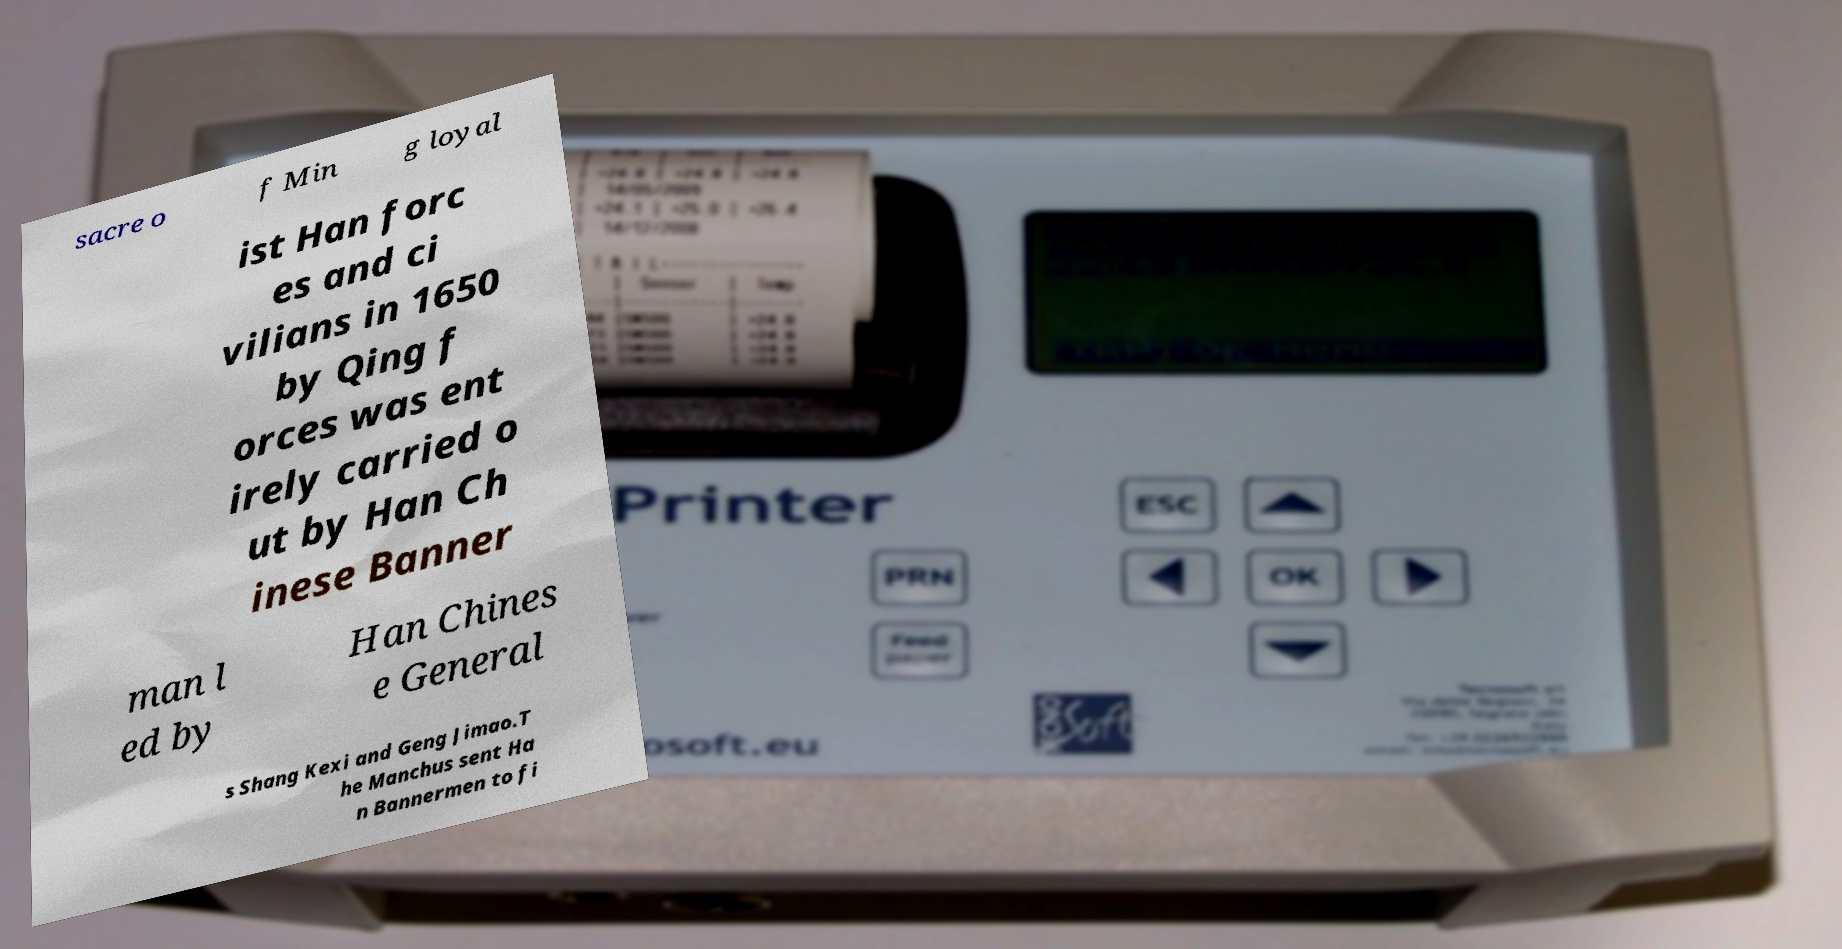Can you read and provide the text displayed in the image?This photo seems to have some interesting text. Can you extract and type it out for me? sacre o f Min g loyal ist Han forc es and ci vilians in 1650 by Qing f orces was ent irely carried o ut by Han Ch inese Banner man l ed by Han Chines e General s Shang Kexi and Geng Jimao.T he Manchus sent Ha n Bannermen to fi 